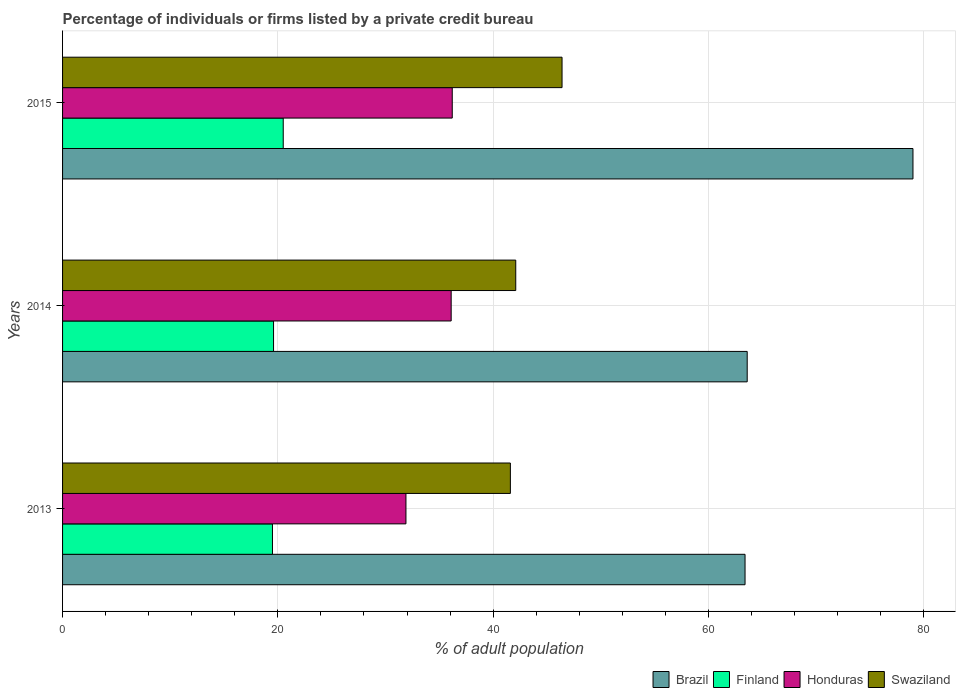How many bars are there on the 3rd tick from the bottom?
Provide a succinct answer. 4. What is the label of the 2nd group of bars from the top?
Your answer should be compact. 2014. In how many cases, is the number of bars for a given year not equal to the number of legend labels?
Offer a terse response. 0. What is the percentage of population listed by a private credit bureau in Honduras in 2015?
Give a very brief answer. 36.2. Across all years, what is the maximum percentage of population listed by a private credit bureau in Honduras?
Offer a terse response. 36.2. Across all years, what is the minimum percentage of population listed by a private credit bureau in Finland?
Your response must be concise. 19.5. In which year was the percentage of population listed by a private credit bureau in Finland maximum?
Your answer should be compact. 2015. What is the total percentage of population listed by a private credit bureau in Finland in the graph?
Offer a terse response. 59.6. What is the difference between the percentage of population listed by a private credit bureau in Swaziland in 2013 and that in 2015?
Provide a succinct answer. -4.8. What is the difference between the percentage of population listed by a private credit bureau in Brazil in 2013 and the percentage of population listed by a private credit bureau in Swaziland in 2015?
Offer a terse response. 17. What is the average percentage of population listed by a private credit bureau in Brazil per year?
Your response must be concise. 68.67. In the year 2015, what is the difference between the percentage of population listed by a private credit bureau in Brazil and percentage of population listed by a private credit bureau in Finland?
Offer a terse response. 58.5. What is the ratio of the percentage of population listed by a private credit bureau in Swaziland in 2014 to that in 2015?
Provide a succinct answer. 0.91. Is the percentage of population listed by a private credit bureau in Finland in 2013 less than that in 2014?
Provide a short and direct response. Yes. What is the difference between the highest and the second highest percentage of population listed by a private credit bureau in Honduras?
Your answer should be very brief. 0.1. What is the difference between the highest and the lowest percentage of population listed by a private credit bureau in Brazil?
Give a very brief answer. 15.6. Is it the case that in every year, the sum of the percentage of population listed by a private credit bureau in Honduras and percentage of population listed by a private credit bureau in Swaziland is greater than the sum of percentage of population listed by a private credit bureau in Finland and percentage of population listed by a private credit bureau in Brazil?
Give a very brief answer. Yes. What does the 4th bar from the top in 2013 represents?
Your answer should be compact. Brazil. What does the 3rd bar from the bottom in 2013 represents?
Your response must be concise. Honduras. Does the graph contain any zero values?
Offer a very short reply. No. Does the graph contain grids?
Provide a short and direct response. Yes. How many legend labels are there?
Offer a very short reply. 4. What is the title of the graph?
Your response must be concise. Percentage of individuals or firms listed by a private credit bureau. What is the label or title of the X-axis?
Your response must be concise. % of adult population. What is the label or title of the Y-axis?
Your answer should be very brief. Years. What is the % of adult population in Brazil in 2013?
Provide a short and direct response. 63.4. What is the % of adult population of Finland in 2013?
Your response must be concise. 19.5. What is the % of adult population in Honduras in 2013?
Your answer should be very brief. 31.9. What is the % of adult population in Swaziland in 2013?
Make the answer very short. 41.6. What is the % of adult population of Brazil in 2014?
Offer a terse response. 63.6. What is the % of adult population of Finland in 2014?
Offer a terse response. 19.6. What is the % of adult population in Honduras in 2014?
Provide a short and direct response. 36.1. What is the % of adult population in Swaziland in 2014?
Keep it short and to the point. 42.1. What is the % of adult population of Brazil in 2015?
Your answer should be compact. 79. What is the % of adult population of Finland in 2015?
Give a very brief answer. 20.5. What is the % of adult population in Honduras in 2015?
Your response must be concise. 36.2. What is the % of adult population in Swaziland in 2015?
Offer a terse response. 46.4. Across all years, what is the maximum % of adult population of Brazil?
Provide a succinct answer. 79. Across all years, what is the maximum % of adult population in Honduras?
Provide a succinct answer. 36.2. Across all years, what is the maximum % of adult population in Swaziland?
Your answer should be compact. 46.4. Across all years, what is the minimum % of adult population in Brazil?
Offer a terse response. 63.4. Across all years, what is the minimum % of adult population of Honduras?
Provide a short and direct response. 31.9. Across all years, what is the minimum % of adult population of Swaziland?
Your answer should be compact. 41.6. What is the total % of adult population of Brazil in the graph?
Provide a short and direct response. 206. What is the total % of adult population of Finland in the graph?
Give a very brief answer. 59.6. What is the total % of adult population in Honduras in the graph?
Keep it short and to the point. 104.2. What is the total % of adult population of Swaziland in the graph?
Offer a very short reply. 130.1. What is the difference between the % of adult population in Brazil in 2013 and that in 2014?
Provide a succinct answer. -0.2. What is the difference between the % of adult population of Honduras in 2013 and that in 2014?
Offer a very short reply. -4.2. What is the difference between the % of adult population of Brazil in 2013 and that in 2015?
Provide a succinct answer. -15.6. What is the difference between the % of adult population of Finland in 2013 and that in 2015?
Your response must be concise. -1. What is the difference between the % of adult population in Honduras in 2013 and that in 2015?
Offer a terse response. -4.3. What is the difference between the % of adult population of Brazil in 2014 and that in 2015?
Provide a succinct answer. -15.4. What is the difference between the % of adult population of Honduras in 2014 and that in 2015?
Ensure brevity in your answer.  -0.1. What is the difference between the % of adult population in Swaziland in 2014 and that in 2015?
Offer a terse response. -4.3. What is the difference between the % of adult population of Brazil in 2013 and the % of adult population of Finland in 2014?
Your response must be concise. 43.8. What is the difference between the % of adult population of Brazil in 2013 and the % of adult population of Honduras in 2014?
Offer a very short reply. 27.3. What is the difference between the % of adult population of Brazil in 2013 and the % of adult population of Swaziland in 2014?
Offer a terse response. 21.3. What is the difference between the % of adult population in Finland in 2013 and the % of adult population in Honduras in 2014?
Provide a succinct answer. -16.6. What is the difference between the % of adult population of Finland in 2013 and the % of adult population of Swaziland in 2014?
Your response must be concise. -22.6. What is the difference between the % of adult population of Brazil in 2013 and the % of adult population of Finland in 2015?
Give a very brief answer. 42.9. What is the difference between the % of adult population of Brazil in 2013 and the % of adult population of Honduras in 2015?
Keep it short and to the point. 27.2. What is the difference between the % of adult population in Brazil in 2013 and the % of adult population in Swaziland in 2015?
Offer a very short reply. 17. What is the difference between the % of adult population of Finland in 2013 and the % of adult population of Honduras in 2015?
Your answer should be compact. -16.7. What is the difference between the % of adult population in Finland in 2013 and the % of adult population in Swaziland in 2015?
Make the answer very short. -26.9. What is the difference between the % of adult population of Brazil in 2014 and the % of adult population of Finland in 2015?
Ensure brevity in your answer.  43.1. What is the difference between the % of adult population in Brazil in 2014 and the % of adult population in Honduras in 2015?
Provide a short and direct response. 27.4. What is the difference between the % of adult population of Finland in 2014 and the % of adult population of Honduras in 2015?
Keep it short and to the point. -16.6. What is the difference between the % of adult population in Finland in 2014 and the % of adult population in Swaziland in 2015?
Make the answer very short. -26.8. What is the difference between the % of adult population in Honduras in 2014 and the % of adult population in Swaziland in 2015?
Make the answer very short. -10.3. What is the average % of adult population of Brazil per year?
Your answer should be very brief. 68.67. What is the average % of adult population of Finland per year?
Provide a succinct answer. 19.87. What is the average % of adult population in Honduras per year?
Provide a short and direct response. 34.73. What is the average % of adult population in Swaziland per year?
Your response must be concise. 43.37. In the year 2013, what is the difference between the % of adult population of Brazil and % of adult population of Finland?
Keep it short and to the point. 43.9. In the year 2013, what is the difference between the % of adult population of Brazil and % of adult population of Honduras?
Your response must be concise. 31.5. In the year 2013, what is the difference between the % of adult population of Brazil and % of adult population of Swaziland?
Provide a succinct answer. 21.8. In the year 2013, what is the difference between the % of adult population of Finland and % of adult population of Swaziland?
Your answer should be compact. -22.1. In the year 2013, what is the difference between the % of adult population of Honduras and % of adult population of Swaziland?
Make the answer very short. -9.7. In the year 2014, what is the difference between the % of adult population in Brazil and % of adult population in Finland?
Provide a short and direct response. 44. In the year 2014, what is the difference between the % of adult population in Brazil and % of adult population in Honduras?
Keep it short and to the point. 27.5. In the year 2014, what is the difference between the % of adult population in Brazil and % of adult population in Swaziland?
Ensure brevity in your answer.  21.5. In the year 2014, what is the difference between the % of adult population in Finland and % of adult population in Honduras?
Your response must be concise. -16.5. In the year 2014, what is the difference between the % of adult population in Finland and % of adult population in Swaziland?
Offer a terse response. -22.5. In the year 2015, what is the difference between the % of adult population of Brazil and % of adult population of Finland?
Keep it short and to the point. 58.5. In the year 2015, what is the difference between the % of adult population in Brazil and % of adult population in Honduras?
Make the answer very short. 42.8. In the year 2015, what is the difference between the % of adult population in Brazil and % of adult population in Swaziland?
Your answer should be very brief. 32.6. In the year 2015, what is the difference between the % of adult population of Finland and % of adult population of Honduras?
Provide a succinct answer. -15.7. In the year 2015, what is the difference between the % of adult population in Finland and % of adult population in Swaziland?
Offer a terse response. -25.9. In the year 2015, what is the difference between the % of adult population in Honduras and % of adult population in Swaziland?
Keep it short and to the point. -10.2. What is the ratio of the % of adult population in Brazil in 2013 to that in 2014?
Provide a succinct answer. 1. What is the ratio of the % of adult population in Finland in 2013 to that in 2014?
Your answer should be very brief. 0.99. What is the ratio of the % of adult population in Honduras in 2013 to that in 2014?
Keep it short and to the point. 0.88. What is the ratio of the % of adult population of Brazil in 2013 to that in 2015?
Keep it short and to the point. 0.8. What is the ratio of the % of adult population in Finland in 2013 to that in 2015?
Your answer should be compact. 0.95. What is the ratio of the % of adult population of Honduras in 2013 to that in 2015?
Ensure brevity in your answer.  0.88. What is the ratio of the % of adult population of Swaziland in 2013 to that in 2015?
Keep it short and to the point. 0.9. What is the ratio of the % of adult population in Brazil in 2014 to that in 2015?
Make the answer very short. 0.81. What is the ratio of the % of adult population of Finland in 2014 to that in 2015?
Your answer should be very brief. 0.96. What is the ratio of the % of adult population of Swaziland in 2014 to that in 2015?
Provide a succinct answer. 0.91. What is the difference between the highest and the second highest % of adult population of Finland?
Give a very brief answer. 0.9. What is the difference between the highest and the lowest % of adult population in Finland?
Make the answer very short. 1. What is the difference between the highest and the lowest % of adult population of Honduras?
Make the answer very short. 4.3. 